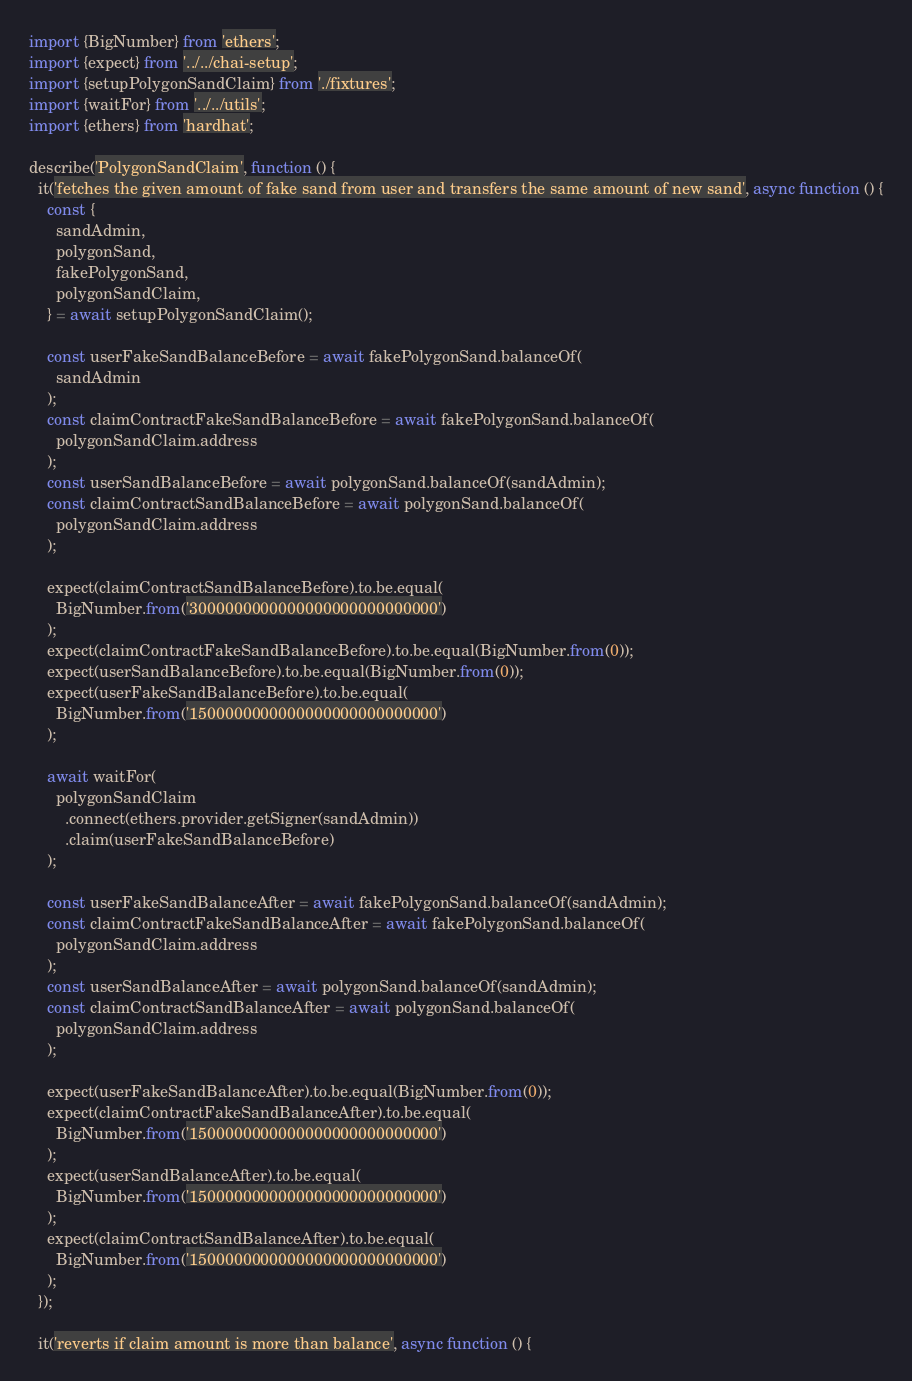<code> <loc_0><loc_0><loc_500><loc_500><_TypeScript_>import {BigNumber} from 'ethers';
import {expect} from '../../chai-setup';
import {setupPolygonSandClaim} from './fixtures';
import {waitFor} from '../../utils';
import {ethers} from 'hardhat';

describe('PolygonSandClaim', function () {
  it('fetches the given amount of fake sand from user and transfers the same amount of new sand', async function () {
    const {
      sandAdmin,
      polygonSand,
      fakePolygonSand,
      polygonSandClaim,
    } = await setupPolygonSandClaim();

    const userFakeSandBalanceBefore = await fakePolygonSand.balanceOf(
      sandAdmin
    );
    const claimContractFakeSandBalanceBefore = await fakePolygonSand.balanceOf(
      polygonSandClaim.address
    );
    const userSandBalanceBefore = await polygonSand.balanceOf(sandAdmin);
    const claimContractSandBalanceBefore = await polygonSand.balanceOf(
      polygonSandClaim.address
    );

    expect(claimContractSandBalanceBefore).to.be.equal(
      BigNumber.from('3000000000000000000000000000')
    );
    expect(claimContractFakeSandBalanceBefore).to.be.equal(BigNumber.from(0));
    expect(userSandBalanceBefore).to.be.equal(BigNumber.from(0));
    expect(userFakeSandBalanceBefore).to.be.equal(
      BigNumber.from('1500000000000000000000000000')
    );

    await waitFor(
      polygonSandClaim
        .connect(ethers.provider.getSigner(sandAdmin))
        .claim(userFakeSandBalanceBefore)
    );

    const userFakeSandBalanceAfter = await fakePolygonSand.balanceOf(sandAdmin);
    const claimContractFakeSandBalanceAfter = await fakePolygonSand.balanceOf(
      polygonSandClaim.address
    );
    const userSandBalanceAfter = await polygonSand.balanceOf(sandAdmin);
    const claimContractSandBalanceAfter = await polygonSand.balanceOf(
      polygonSandClaim.address
    );

    expect(userFakeSandBalanceAfter).to.be.equal(BigNumber.from(0));
    expect(claimContractFakeSandBalanceAfter).to.be.equal(
      BigNumber.from('1500000000000000000000000000')
    );
    expect(userSandBalanceAfter).to.be.equal(
      BigNumber.from('1500000000000000000000000000')
    );
    expect(claimContractSandBalanceAfter).to.be.equal(
      BigNumber.from('1500000000000000000000000000')
    );
  });

  it('reverts if claim amount is more than balance', async function () {</code> 